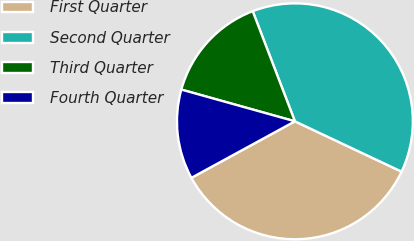<chart> <loc_0><loc_0><loc_500><loc_500><pie_chart><fcel>First Quarter<fcel>Second Quarter<fcel>Third Quarter<fcel>Fourth Quarter<nl><fcel>35.03%<fcel>37.84%<fcel>14.84%<fcel>12.29%<nl></chart> 